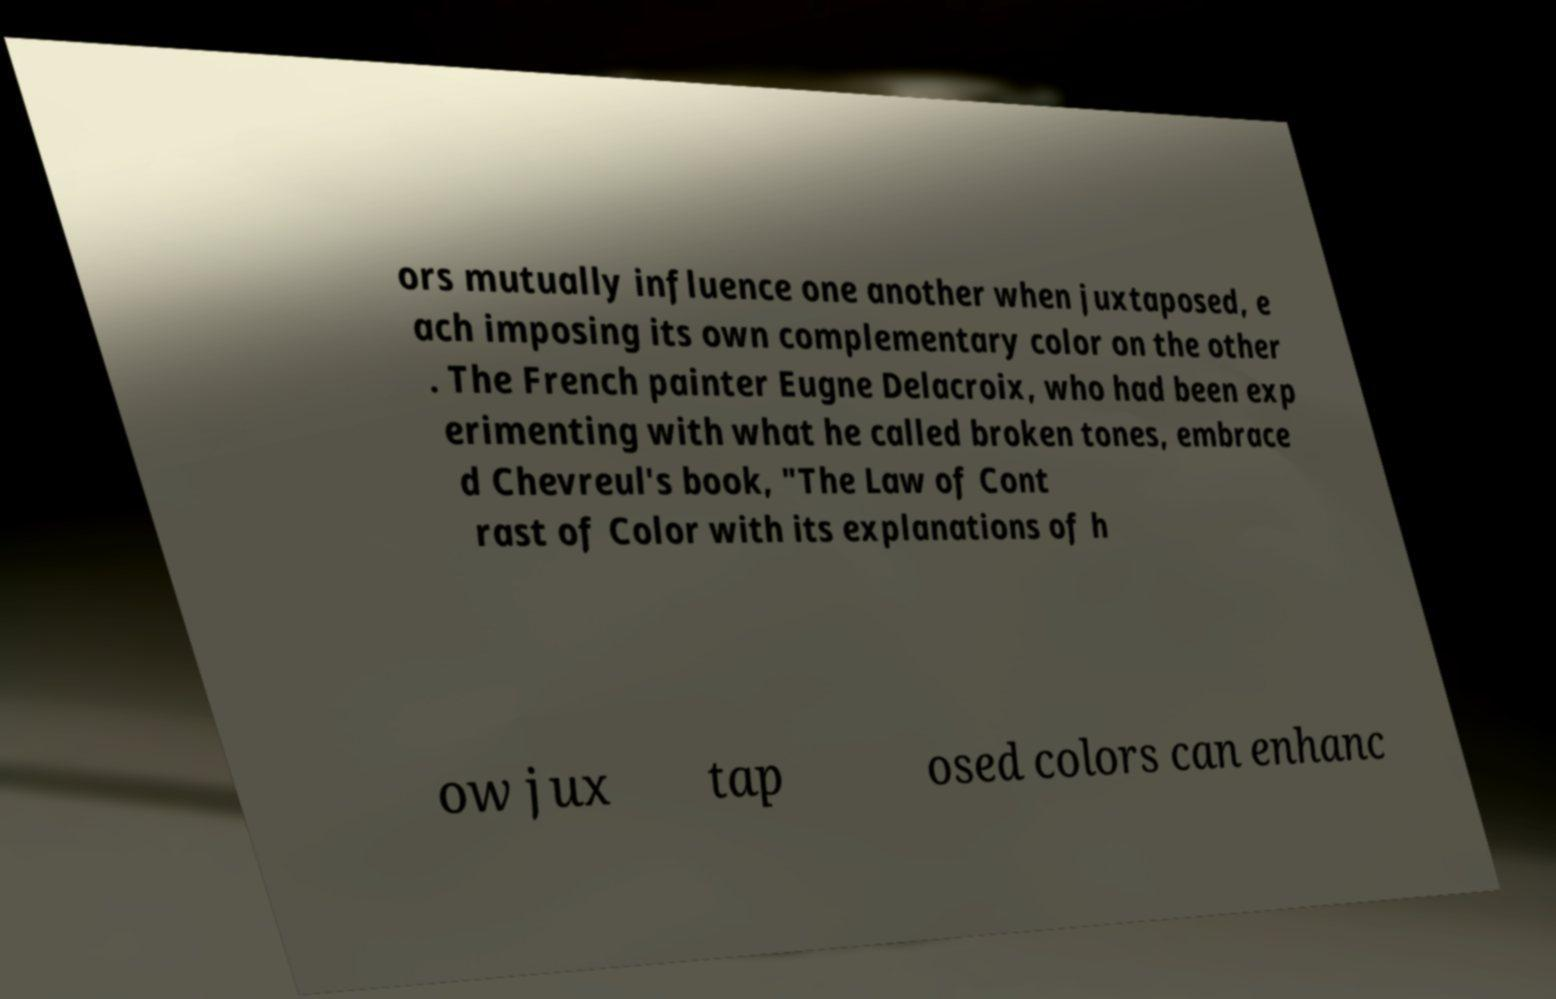I need the written content from this picture converted into text. Can you do that? ors mutually influence one another when juxtaposed, e ach imposing its own complementary color on the other . The French painter Eugne Delacroix, who had been exp erimenting with what he called broken tones, embrace d Chevreul's book, "The Law of Cont rast of Color with its explanations of h ow jux tap osed colors can enhanc 